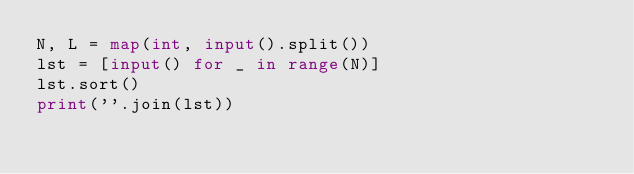<code> <loc_0><loc_0><loc_500><loc_500><_Python_>N, L = map(int, input().split())
lst = [input() for _ in range(N)]
lst.sort()
print(''.join(lst))</code> 